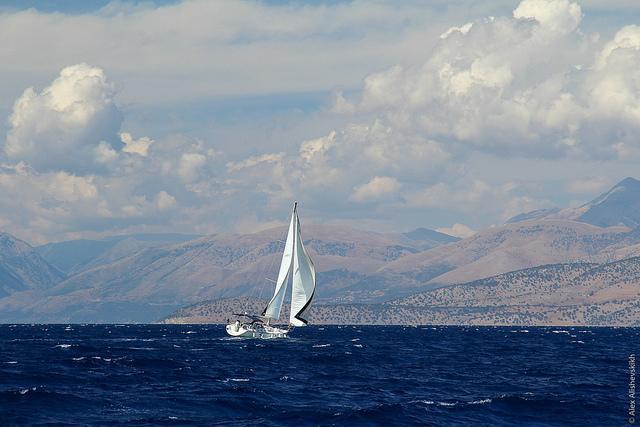How many baby zebras are there?
Give a very brief answer. 0. 